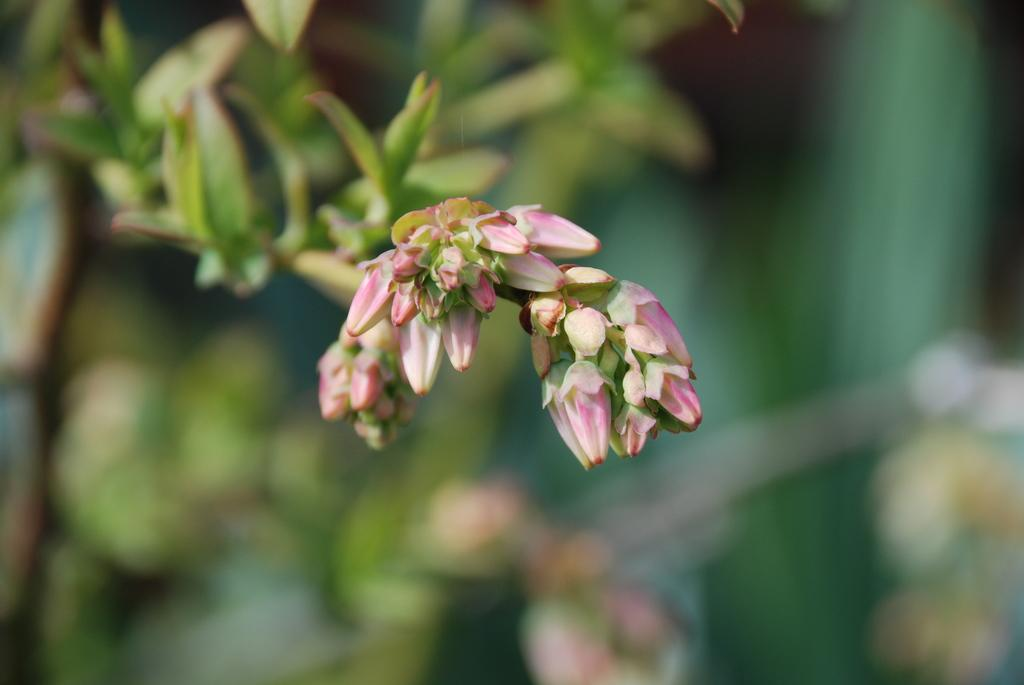What type of plant life is visible in the image? There are flower buds and leaves in the image. How are the flower buds connected to the rest of the plant? The flower buds are attached to stems in the image. What can be seen in the background of the image? The background of the image appears blurry. What type of soup is being served in the image? There is no soup present in the image; it features flower buds, stems, and leaves. Is there a letter addressed to someone in the image? There is no letter present in the image; it features flower buds, stems, and leaves. 